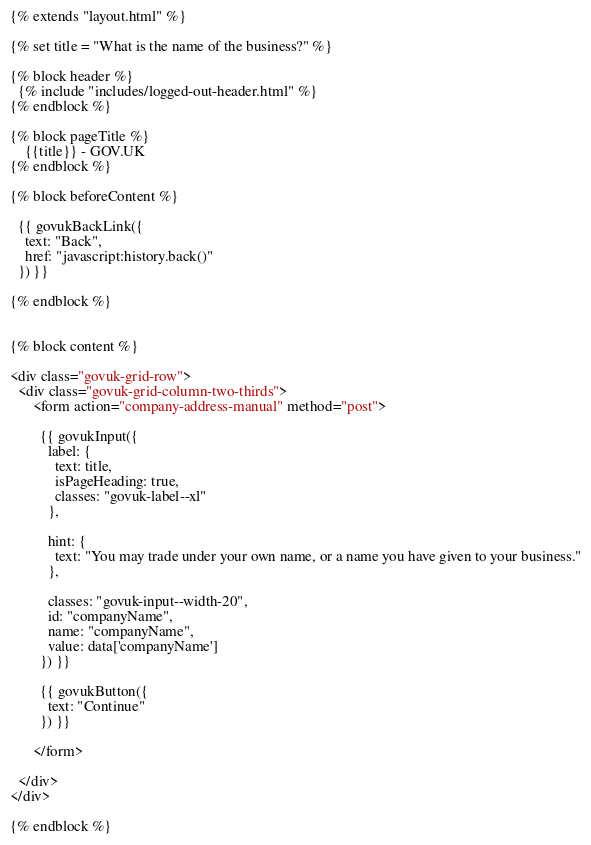<code> <loc_0><loc_0><loc_500><loc_500><_HTML_>{% extends "layout.html" %}

{% set title = "What is the name of the business?" %}

{% block header %}
  {% include "includes/logged-out-header.html" %}
{% endblock %}

{% block pageTitle %}
    {{title}} - GOV.UK
{% endblock %}

{% block beforeContent %}

  {{ govukBackLink({
    text: "Back",
    href: "javascript:history.back()"
  }) }}

{% endblock %}


{% block content %}

<div class="govuk-grid-row">
  <div class="govuk-grid-column-two-thirds">
      <form action="company-address-manual" method="post">

        {{ govukInput({
          label: {
            text: title,
            isPageHeading: true,
            classes: "govuk-label--xl"
          },

          hint: {
            text: "You may trade under your own name, or a name you have given to your business."
          },

          classes: "govuk-input--width-20",
          id: "companyName",
          name: "companyName",
          value: data['companyName']
        }) }}

        {{ govukButton({
          text: "Continue"
        }) }}

      </form>

  </div>
</div>

{% endblock %}
</code> 